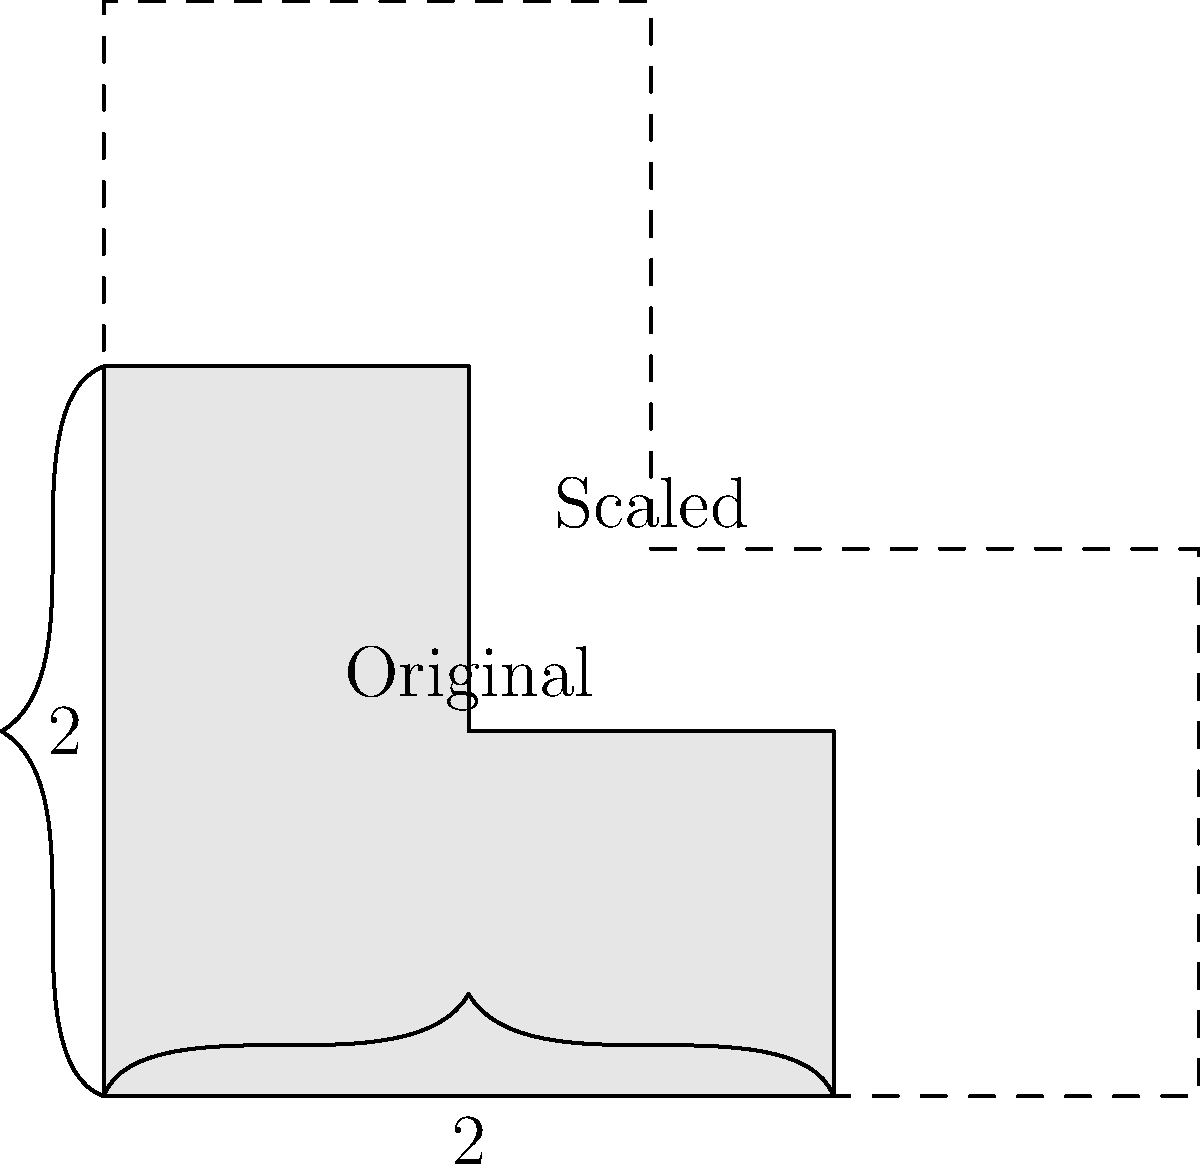In the diagram above, a complex L-shaped figure is shown. The original figure has a width of 2 units and a height of 2 units. If this figure is scaled by a factor of 1.5, what is the new area of the scaled figure? To solve this problem, we'll follow these steps:

1. Calculate the area of the original figure:
   The L-shape can be divided into two rectangles:
   - Rectangle 1: 2 x 1 = 2 square units
   - Rectangle 2: 1 x 1 = 1 square unit
   Total area = 2 + 1 = 3 square units

2. Understand the scaling factor:
   The figure is scaled by a factor of 1.5, which means all dimensions are multiplied by 1.5.

3. Calculate the effect of scaling on area:
   When a 2D shape is scaled by a factor of k, its area is scaled by a factor of $k^2$.
   In this case, $k = 1.5$, so the area scale factor is $1.5^2 = 2.25$.

4. Calculate the new area:
   New area = Original area × Area scale factor
   New area = 3 × 2.25 = 6.75 square units

Therefore, the new area of the scaled figure is 6.75 square units.
Answer: 6.75 square units 